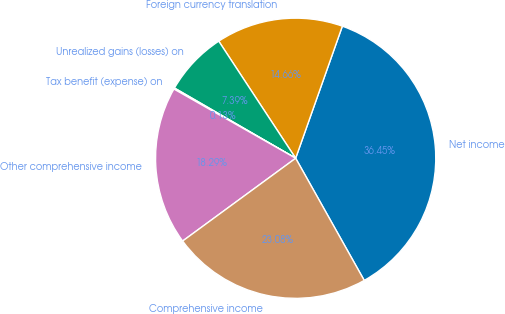<chart> <loc_0><loc_0><loc_500><loc_500><pie_chart><fcel>Net income<fcel>Foreign currency translation<fcel>Unrealized gains (losses) on<fcel>Tax benefit (expense) on<fcel>Other comprehensive income<fcel>Comprehensive income<nl><fcel>36.45%<fcel>14.66%<fcel>7.39%<fcel>0.13%<fcel>18.29%<fcel>23.08%<nl></chart> 